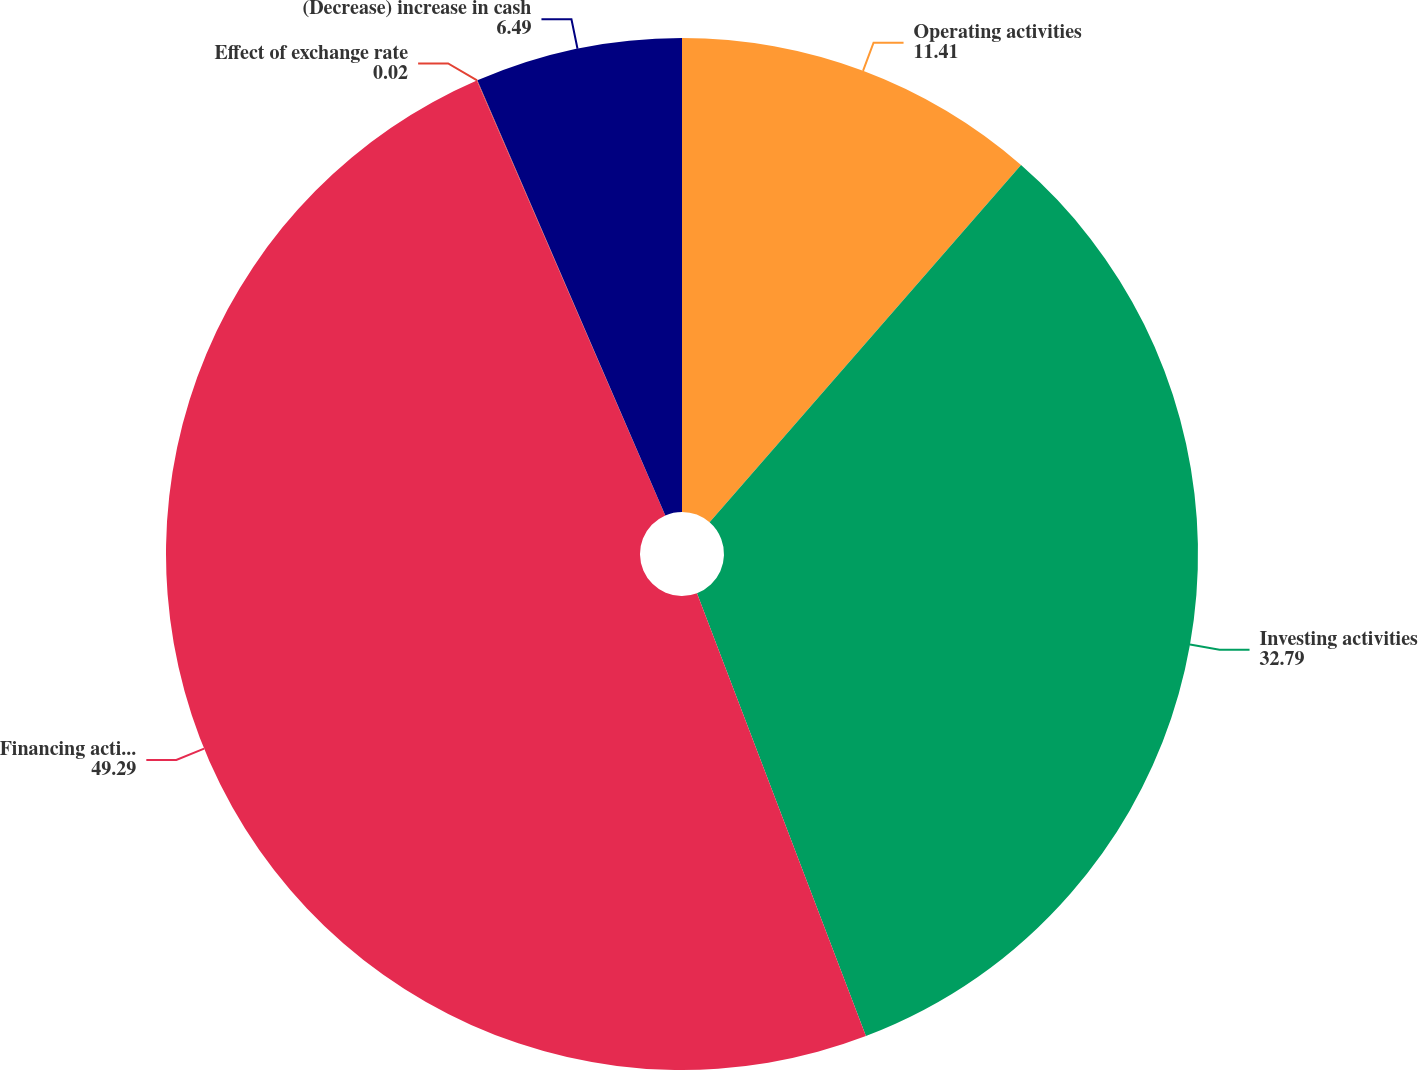Convert chart. <chart><loc_0><loc_0><loc_500><loc_500><pie_chart><fcel>Operating activities<fcel>Investing activities<fcel>Financing activities<fcel>Effect of exchange rate<fcel>(Decrease) increase in cash<nl><fcel>11.41%<fcel>32.79%<fcel>49.29%<fcel>0.02%<fcel>6.49%<nl></chart> 